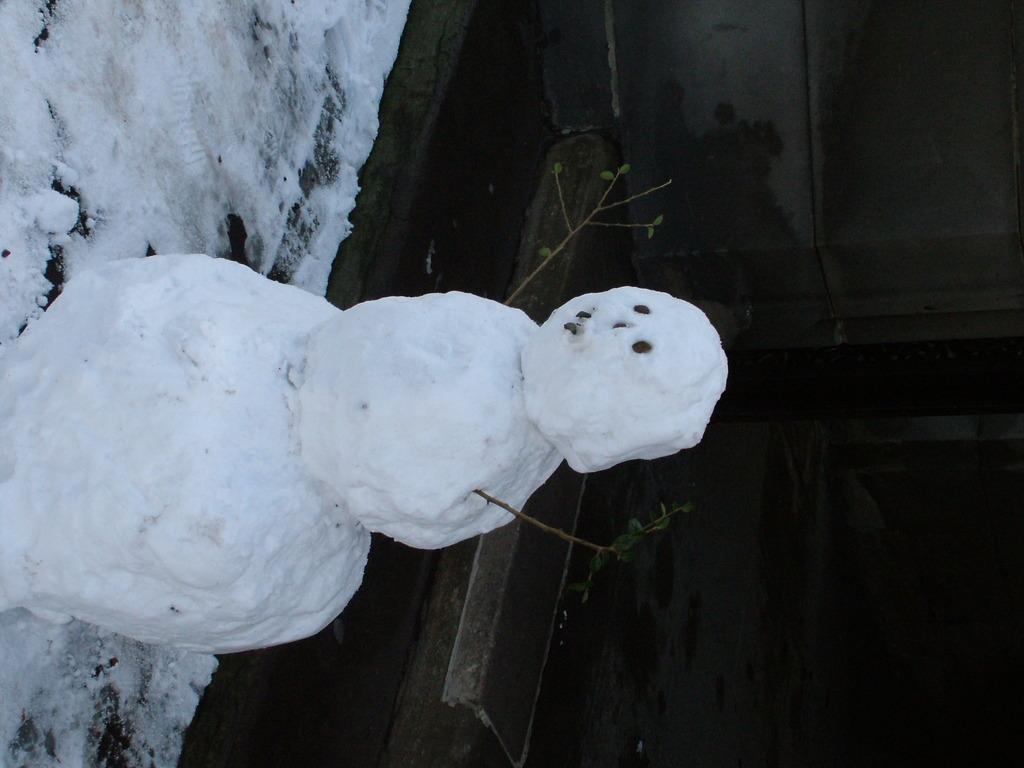Describe this image in one or two sentences. In this image I can see a snowman. Here I can see the snow and other objects. The background of the image is dark. 